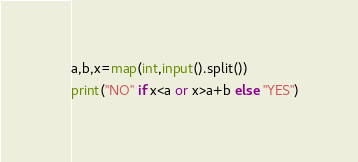Convert code to text. <code><loc_0><loc_0><loc_500><loc_500><_Python_>a,b,x=map(int,input().split())
print("NO" if x<a or x>a+b else "YES")</code> 